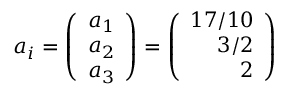Convert formula to latex. <formula><loc_0><loc_0><loc_500><loc_500>a _ { i } = \left ( \begin{array} { r } { { a _ { 1 } } } \\ { { a _ { 2 } } } \\ { { a _ { 3 } } } \end{array} \right ) = \left ( \begin{array} { r } { 1 7 / 1 0 } \\ { 3 / 2 } \\ { 2 } \end{array} \right )</formula> 